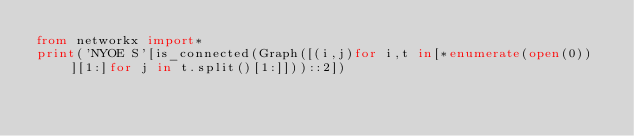Convert code to text. <code><loc_0><loc_0><loc_500><loc_500><_Python_>from networkx import*
print('NYOE S'[is_connected(Graph([(i,j)for i,t in[*enumerate(open(0))][1:]for j in t.split()[1:]]))::2])</code> 